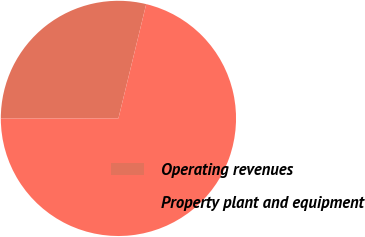<chart> <loc_0><loc_0><loc_500><loc_500><pie_chart><fcel>Operating revenues<fcel>Property plant and equipment<nl><fcel>28.82%<fcel>71.18%<nl></chart> 